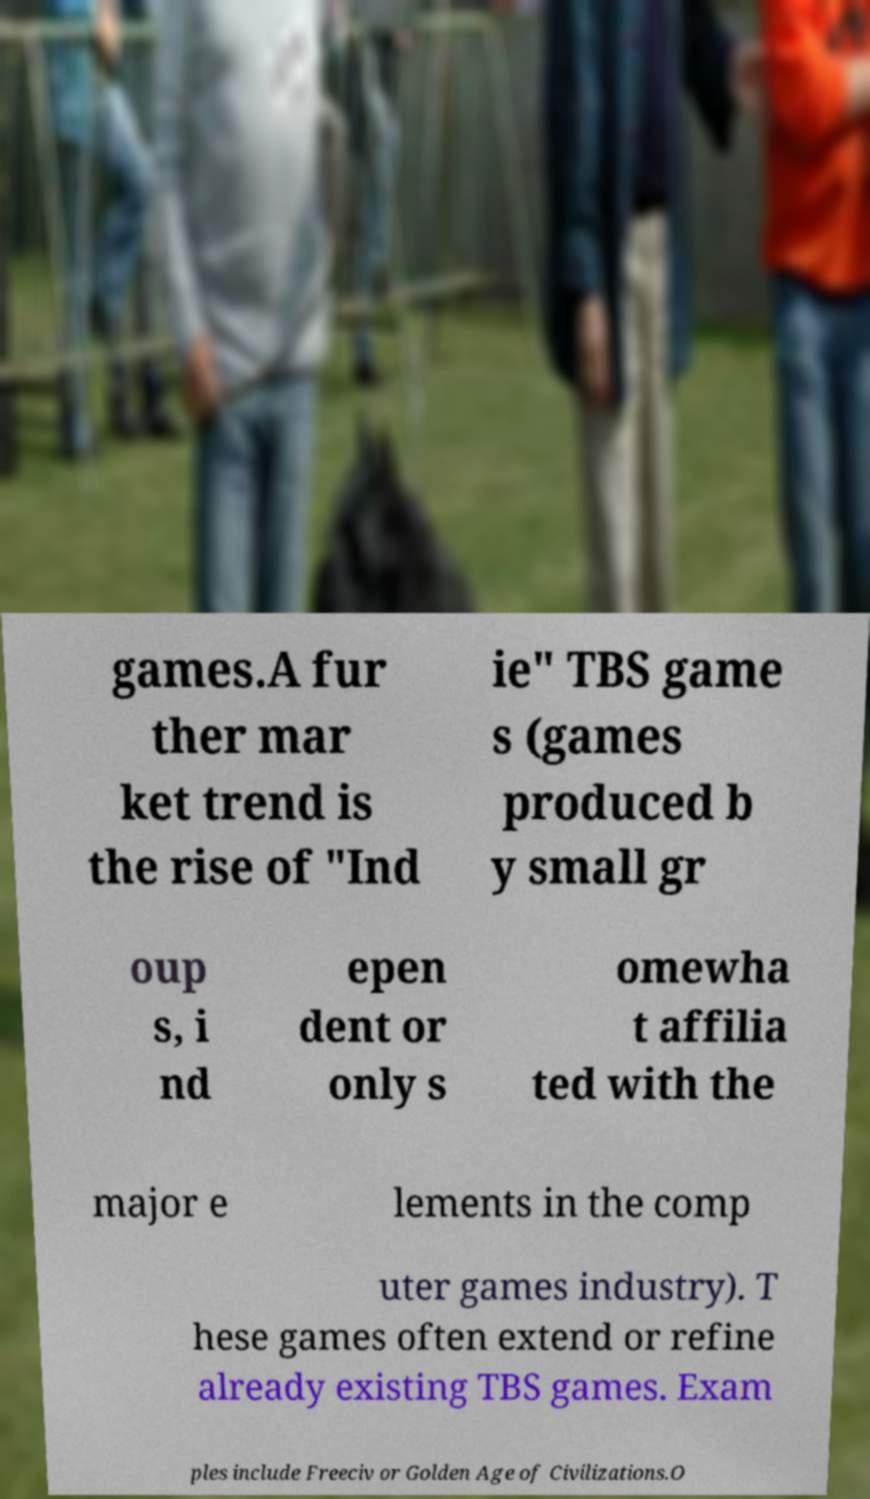There's text embedded in this image that I need extracted. Can you transcribe it verbatim? games.A fur ther mar ket trend is the rise of "Ind ie" TBS game s (games produced b y small gr oup s, i nd epen dent or only s omewha t affilia ted with the major e lements in the comp uter games industry). T hese games often extend or refine already existing TBS games. Exam ples include Freeciv or Golden Age of Civilizations.O 